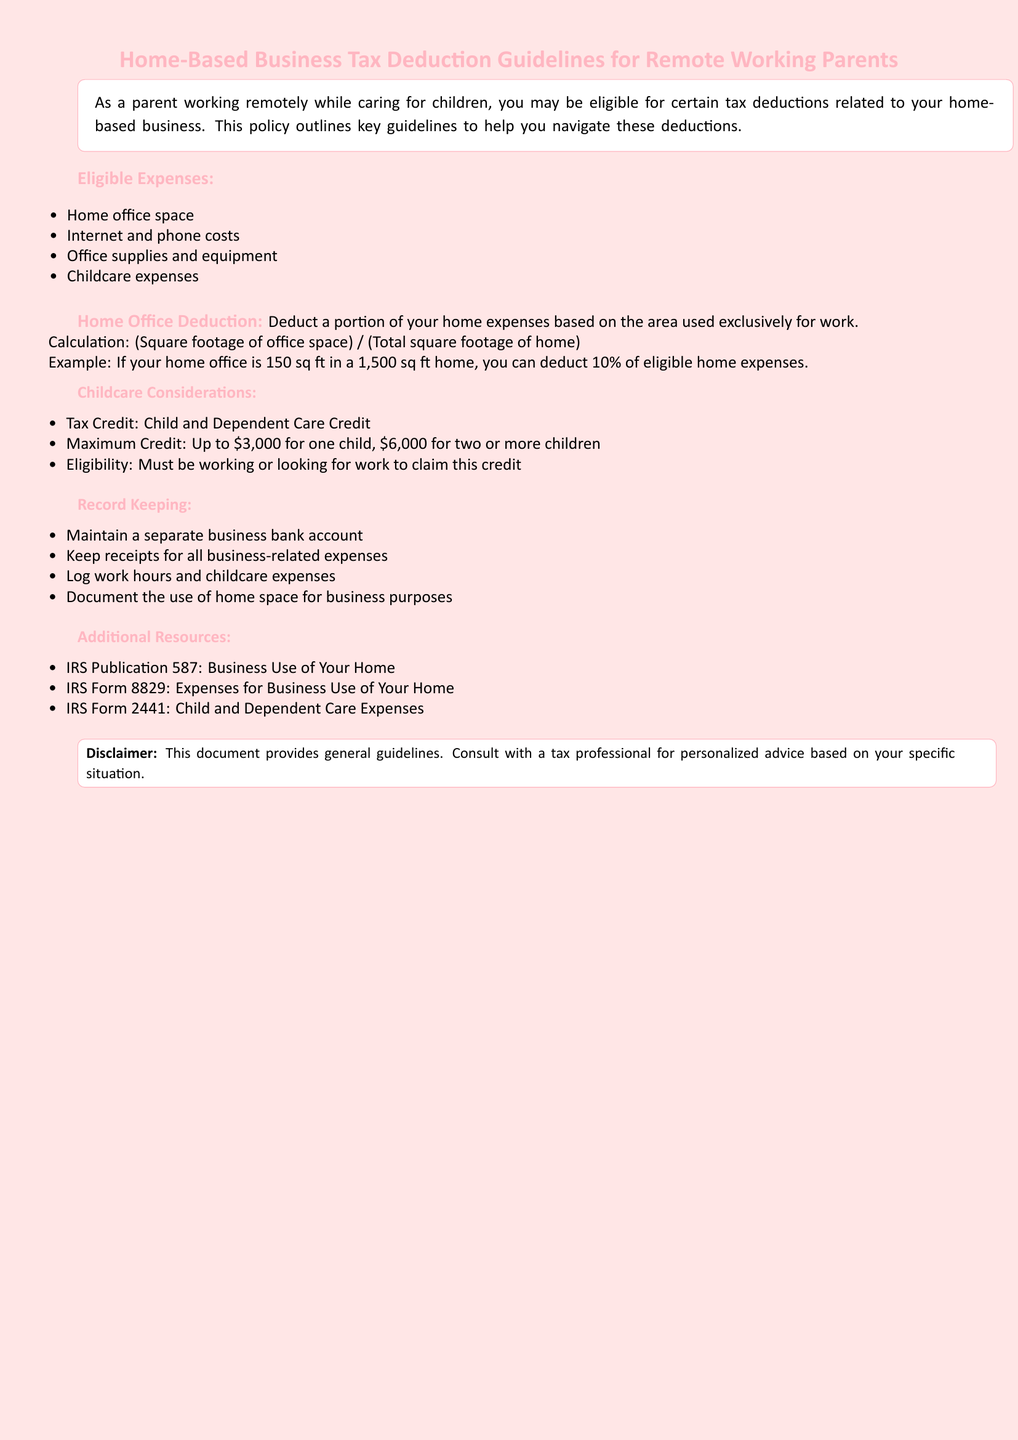What are eligible expenses for home-based business deductions? The document lists specific expenses that can be deducted, including home office space, internet and phone costs, office supplies, and childcare expenses.
Answer: home office space, internet and phone costs, office supplies, childcare expenses What is the maximum credit for two or more children? The document states the maximum credit amount available for parents with two or more children for childcare is $6,000.
Answer: $6,000 How is the home office deduction calculated? The document explains that the deduction is based on the formula of square footage of the office space divided by the total square footage of the home.
Answer: (Square footage of office space) / (Total square footage of home) What is IRS Form 8829 for? The document indicates that IRS Form 8829 is used for claiming expenses related to business use of the home.
Answer: Expenses for Business Use of Your Home What does the document recommend for record keeping? The document mentions various practices for record-keeping, including maintaining a separate business bank account and keeping receipts.
Answer: Maintain a separate business bank account What is the calculation example provided for home office space? The example given in the document explains that if the office is 150 sq ft in a 1,500 sq ft home, then 10% of eligible home expenses can be deducted.
Answer: 10% What must you do to claim the Child and Dependent Care Credit? The document specifies that you must be working or looking for work to be eligible for the credit.
Answer: Must be working or looking for work What is the purpose of the disclaimer at the end of the document? The document asserts that the disclaimer provides a caution about the general nature of the guidelines and the importance of consulting a tax professional.
Answer: Consult with a tax professional 